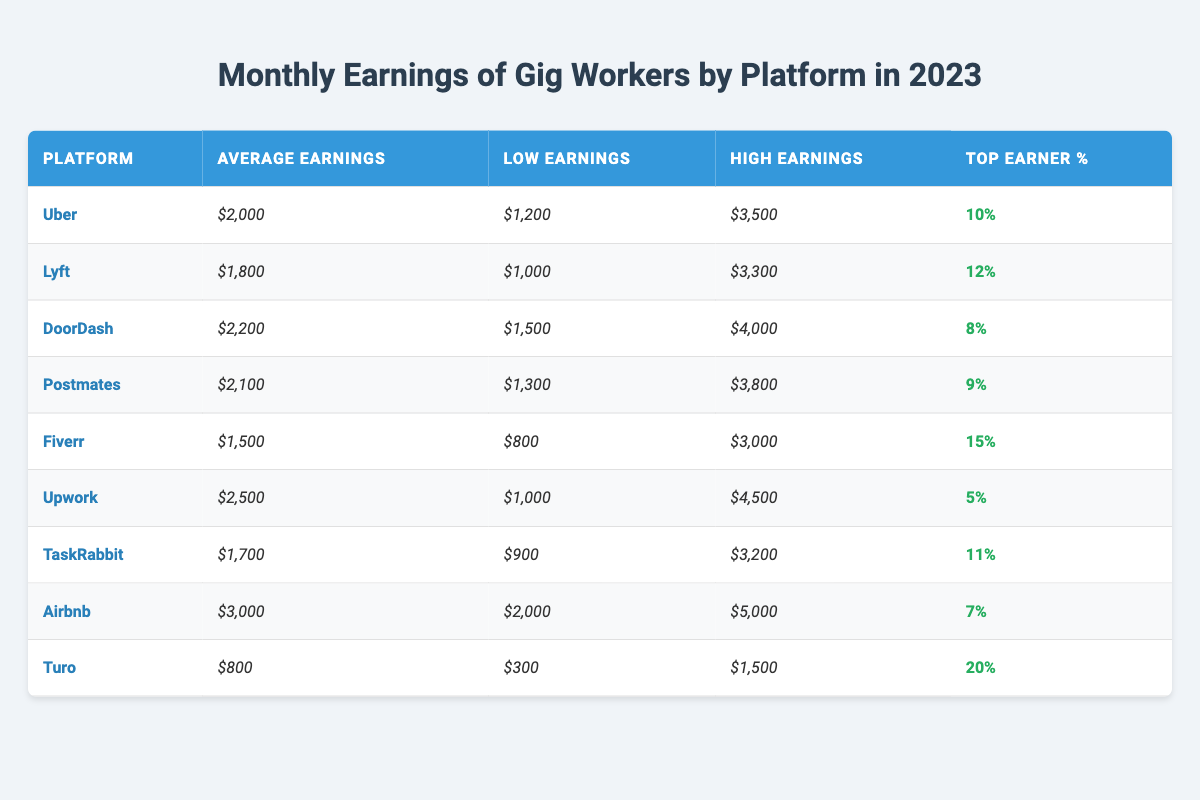What is the average earnings for Uber drivers? According to the table, the average earnings for Uber drivers is listed directly as $2,000.
Answer: $2,000 Which platform has the highest average earnings? The table shows that Upwork has the highest average earnings at $2,500.
Answer: Upwork What percentage of Fiverr users are top earners? The table indicates that 15% of Fiverr users are categorized as top earners.
Answer: 15% Is the lowest earning reported for TaskRabbit more than $800? By checking the table, the low earnings for TaskRabbit are $900, which is indeed more than $800.
Answer: Yes What is the difference between the average earnings of DoorDash and Lyft? To find the difference, subtract the average earnings of Lyft ($1,800) from DoorDash ($2,200). The result is $2,200 - $1,800 = $400.
Answer: $400 If we take the average earnings of Airbnb and Turo, what will that be? The average earnings for Airbnb are $3,000, and for Turo it is $800. The average of these two is calculated as (3,000 + 800) / 2 = 1,900.
Answer: $1,900 How many platforms have an average earning of more than $2,000? By reviewing the average earnings for each platform, we find that DoorDash, Postmates, Upwork, and Airbnb have averages above $2,000. This amounts to four platforms.
Answer: 4 Which platform has the widest range between low and high earnings? The range can be calculated by subtracting the low earnings from the high earnings for each platform. DoorDash has a range of $4,000 - $1,500 = $2,500, which is the widest among all platforms.
Answer: DoorDash Is the average earning for Lyft less than the average earning for TaskRabbit? Comparing the average earnings, Lyft's average is $1,800 while TaskRabbit's average is $1,700. Hence, Lyft's average is greater than TaskRabbit's.
Answer: No What is the total average earnings for all the platforms listed in the table? The total average earnings can be found by adding together all the averages listed: 2000 + 1800 + 2200 + 2100 + 1500 + 2500 + 1700 + 3000 + 800 = 20,100. There are 9 platforms, so the overall average is 20,100 / 9 = 2,233.33 (approximately).
Answer: $2,233.33 